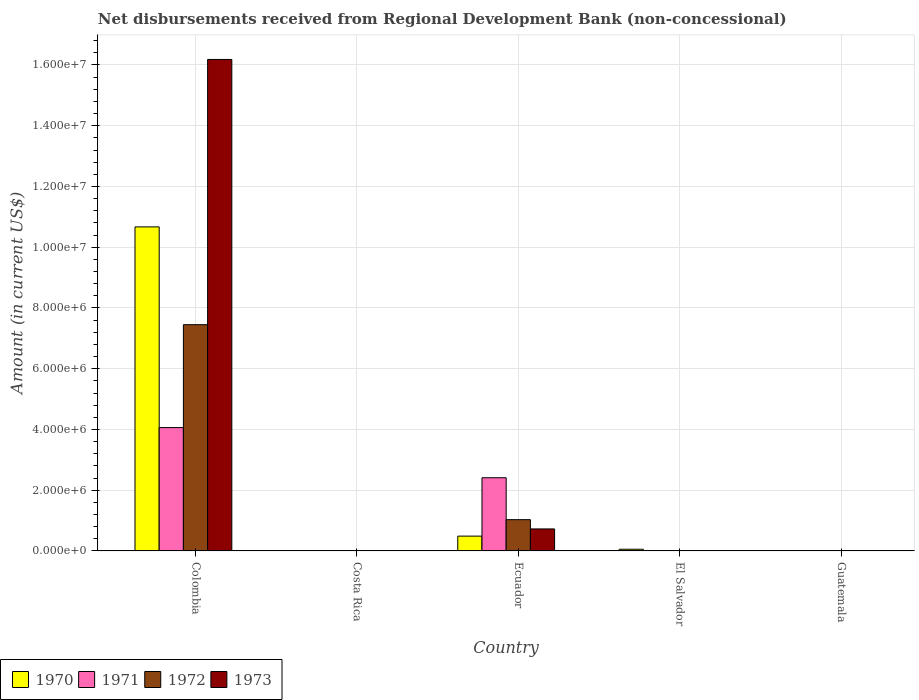How many different coloured bars are there?
Offer a terse response. 4. Are the number of bars per tick equal to the number of legend labels?
Ensure brevity in your answer.  No. Are the number of bars on each tick of the X-axis equal?
Provide a succinct answer. No. How many bars are there on the 4th tick from the left?
Ensure brevity in your answer.  1. How many bars are there on the 2nd tick from the right?
Offer a very short reply. 1. What is the label of the 4th group of bars from the left?
Offer a very short reply. El Salvador. Across all countries, what is the maximum amount of disbursements received from Regional Development Bank in 1970?
Offer a very short reply. 1.07e+07. What is the total amount of disbursements received from Regional Development Bank in 1972 in the graph?
Keep it short and to the point. 8.48e+06. What is the difference between the amount of disbursements received from Regional Development Bank in 1973 in Colombia and that in Ecuador?
Provide a short and direct response. 1.55e+07. What is the difference between the amount of disbursements received from Regional Development Bank in 1971 in Guatemala and the amount of disbursements received from Regional Development Bank in 1970 in Colombia?
Your response must be concise. -1.07e+07. What is the average amount of disbursements received from Regional Development Bank in 1972 per country?
Ensure brevity in your answer.  1.70e+06. What is the difference between the amount of disbursements received from Regional Development Bank of/in 1971 and amount of disbursements received from Regional Development Bank of/in 1970 in Colombia?
Provide a succinct answer. -6.61e+06. What is the ratio of the amount of disbursements received from Regional Development Bank in 1973 in Colombia to that in Ecuador?
Your response must be concise. 22.29. Is the difference between the amount of disbursements received from Regional Development Bank in 1971 in Colombia and Ecuador greater than the difference between the amount of disbursements received from Regional Development Bank in 1970 in Colombia and Ecuador?
Provide a short and direct response. No. What is the difference between the highest and the lowest amount of disbursements received from Regional Development Bank in 1971?
Your response must be concise. 4.06e+06. In how many countries, is the amount of disbursements received from Regional Development Bank in 1970 greater than the average amount of disbursements received from Regional Development Bank in 1970 taken over all countries?
Give a very brief answer. 1. Is the sum of the amount of disbursements received from Regional Development Bank in 1972 in Colombia and Ecuador greater than the maximum amount of disbursements received from Regional Development Bank in 1971 across all countries?
Make the answer very short. Yes. How many countries are there in the graph?
Provide a short and direct response. 5. What is the difference between two consecutive major ticks on the Y-axis?
Your response must be concise. 2.00e+06. Are the values on the major ticks of Y-axis written in scientific E-notation?
Offer a terse response. Yes. Does the graph contain any zero values?
Offer a very short reply. Yes. Does the graph contain grids?
Offer a very short reply. Yes. Where does the legend appear in the graph?
Give a very brief answer. Bottom left. What is the title of the graph?
Ensure brevity in your answer.  Net disbursements received from Regional Development Bank (non-concessional). What is the label or title of the Y-axis?
Give a very brief answer. Amount (in current US$). What is the Amount (in current US$) in 1970 in Colombia?
Offer a very short reply. 1.07e+07. What is the Amount (in current US$) in 1971 in Colombia?
Your response must be concise. 4.06e+06. What is the Amount (in current US$) in 1972 in Colombia?
Give a very brief answer. 7.45e+06. What is the Amount (in current US$) of 1973 in Colombia?
Your answer should be very brief. 1.62e+07. What is the Amount (in current US$) of 1970 in Costa Rica?
Provide a short and direct response. 0. What is the Amount (in current US$) of 1971 in Costa Rica?
Keep it short and to the point. 0. What is the Amount (in current US$) in 1973 in Costa Rica?
Your response must be concise. 0. What is the Amount (in current US$) in 1970 in Ecuador?
Give a very brief answer. 4.89e+05. What is the Amount (in current US$) of 1971 in Ecuador?
Your response must be concise. 2.41e+06. What is the Amount (in current US$) in 1972 in Ecuador?
Your answer should be compact. 1.03e+06. What is the Amount (in current US$) of 1973 in Ecuador?
Give a very brief answer. 7.26e+05. What is the Amount (in current US$) of 1970 in El Salvador?
Keep it short and to the point. 5.70e+04. What is the Amount (in current US$) of 1972 in El Salvador?
Provide a succinct answer. 0. What is the Amount (in current US$) in 1972 in Guatemala?
Ensure brevity in your answer.  0. Across all countries, what is the maximum Amount (in current US$) of 1970?
Your answer should be very brief. 1.07e+07. Across all countries, what is the maximum Amount (in current US$) in 1971?
Offer a terse response. 4.06e+06. Across all countries, what is the maximum Amount (in current US$) in 1972?
Give a very brief answer. 7.45e+06. Across all countries, what is the maximum Amount (in current US$) of 1973?
Your answer should be very brief. 1.62e+07. Across all countries, what is the minimum Amount (in current US$) of 1973?
Make the answer very short. 0. What is the total Amount (in current US$) of 1970 in the graph?
Your answer should be very brief. 1.12e+07. What is the total Amount (in current US$) in 1971 in the graph?
Offer a terse response. 6.47e+06. What is the total Amount (in current US$) in 1972 in the graph?
Give a very brief answer. 8.48e+06. What is the total Amount (in current US$) in 1973 in the graph?
Ensure brevity in your answer.  1.69e+07. What is the difference between the Amount (in current US$) in 1970 in Colombia and that in Ecuador?
Give a very brief answer. 1.02e+07. What is the difference between the Amount (in current US$) of 1971 in Colombia and that in Ecuador?
Ensure brevity in your answer.  1.65e+06. What is the difference between the Amount (in current US$) in 1972 in Colombia and that in Ecuador?
Your answer should be very brief. 6.42e+06. What is the difference between the Amount (in current US$) of 1973 in Colombia and that in Ecuador?
Offer a very short reply. 1.55e+07. What is the difference between the Amount (in current US$) of 1970 in Colombia and that in El Salvador?
Give a very brief answer. 1.06e+07. What is the difference between the Amount (in current US$) in 1970 in Ecuador and that in El Salvador?
Offer a terse response. 4.32e+05. What is the difference between the Amount (in current US$) of 1970 in Colombia and the Amount (in current US$) of 1971 in Ecuador?
Offer a very short reply. 8.26e+06. What is the difference between the Amount (in current US$) of 1970 in Colombia and the Amount (in current US$) of 1972 in Ecuador?
Make the answer very short. 9.64e+06. What is the difference between the Amount (in current US$) of 1970 in Colombia and the Amount (in current US$) of 1973 in Ecuador?
Give a very brief answer. 9.94e+06. What is the difference between the Amount (in current US$) of 1971 in Colombia and the Amount (in current US$) of 1972 in Ecuador?
Offer a very short reply. 3.03e+06. What is the difference between the Amount (in current US$) of 1971 in Colombia and the Amount (in current US$) of 1973 in Ecuador?
Offer a very short reply. 3.34e+06. What is the difference between the Amount (in current US$) in 1972 in Colombia and the Amount (in current US$) in 1973 in Ecuador?
Make the answer very short. 6.72e+06. What is the average Amount (in current US$) in 1970 per country?
Give a very brief answer. 2.24e+06. What is the average Amount (in current US$) in 1971 per country?
Your answer should be compact. 1.29e+06. What is the average Amount (in current US$) of 1972 per country?
Your response must be concise. 1.70e+06. What is the average Amount (in current US$) in 1973 per country?
Your response must be concise. 3.38e+06. What is the difference between the Amount (in current US$) in 1970 and Amount (in current US$) in 1971 in Colombia?
Your response must be concise. 6.61e+06. What is the difference between the Amount (in current US$) in 1970 and Amount (in current US$) in 1972 in Colombia?
Offer a terse response. 3.22e+06. What is the difference between the Amount (in current US$) in 1970 and Amount (in current US$) in 1973 in Colombia?
Provide a succinct answer. -5.51e+06. What is the difference between the Amount (in current US$) of 1971 and Amount (in current US$) of 1972 in Colombia?
Make the answer very short. -3.39e+06. What is the difference between the Amount (in current US$) in 1971 and Amount (in current US$) in 1973 in Colombia?
Make the answer very short. -1.21e+07. What is the difference between the Amount (in current US$) of 1972 and Amount (in current US$) of 1973 in Colombia?
Your response must be concise. -8.73e+06. What is the difference between the Amount (in current US$) of 1970 and Amount (in current US$) of 1971 in Ecuador?
Your response must be concise. -1.92e+06. What is the difference between the Amount (in current US$) in 1970 and Amount (in current US$) in 1972 in Ecuador?
Offer a terse response. -5.42e+05. What is the difference between the Amount (in current US$) in 1970 and Amount (in current US$) in 1973 in Ecuador?
Provide a succinct answer. -2.37e+05. What is the difference between the Amount (in current US$) of 1971 and Amount (in current US$) of 1972 in Ecuador?
Ensure brevity in your answer.  1.38e+06. What is the difference between the Amount (in current US$) of 1971 and Amount (in current US$) of 1973 in Ecuador?
Your response must be concise. 1.68e+06. What is the difference between the Amount (in current US$) in 1972 and Amount (in current US$) in 1973 in Ecuador?
Give a very brief answer. 3.05e+05. What is the ratio of the Amount (in current US$) in 1970 in Colombia to that in Ecuador?
Keep it short and to the point. 21.82. What is the ratio of the Amount (in current US$) of 1971 in Colombia to that in Ecuador?
Make the answer very short. 1.68. What is the ratio of the Amount (in current US$) in 1972 in Colombia to that in Ecuador?
Make the answer very short. 7.23. What is the ratio of the Amount (in current US$) in 1973 in Colombia to that in Ecuador?
Your answer should be compact. 22.29. What is the ratio of the Amount (in current US$) in 1970 in Colombia to that in El Salvador?
Make the answer very short. 187.19. What is the ratio of the Amount (in current US$) in 1970 in Ecuador to that in El Salvador?
Provide a succinct answer. 8.58. What is the difference between the highest and the second highest Amount (in current US$) of 1970?
Your answer should be very brief. 1.02e+07. What is the difference between the highest and the lowest Amount (in current US$) of 1970?
Offer a very short reply. 1.07e+07. What is the difference between the highest and the lowest Amount (in current US$) of 1971?
Your answer should be very brief. 4.06e+06. What is the difference between the highest and the lowest Amount (in current US$) of 1972?
Keep it short and to the point. 7.45e+06. What is the difference between the highest and the lowest Amount (in current US$) of 1973?
Provide a succinct answer. 1.62e+07. 